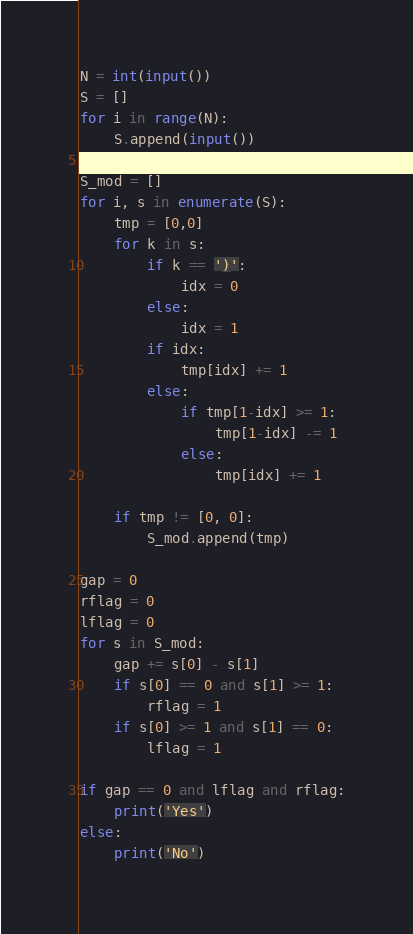Convert code to text. <code><loc_0><loc_0><loc_500><loc_500><_Python_>N = int(input())
S = []
for i in range(N):
    S.append(input())

S_mod = []
for i, s in enumerate(S):
    tmp = [0,0]
    for k in s:
        if k == ')':
            idx = 0
        else:
            idx = 1
        if idx:
            tmp[idx] += 1
        else:
            if tmp[1-idx] >= 1:
                tmp[1-idx] -= 1
            else:
                tmp[idx] += 1

    if tmp != [0, 0]:
        S_mod.append(tmp)

gap = 0
rflag = 0
lflag = 0
for s in S_mod:
    gap += s[0] - s[1]
    if s[0] == 0 and s[1] >= 1:
        rflag = 1
    if s[0] >= 1 and s[1] == 0:
        lflag = 1

if gap == 0 and lflag and rflag:
    print('Yes')
else:
    print('No')</code> 